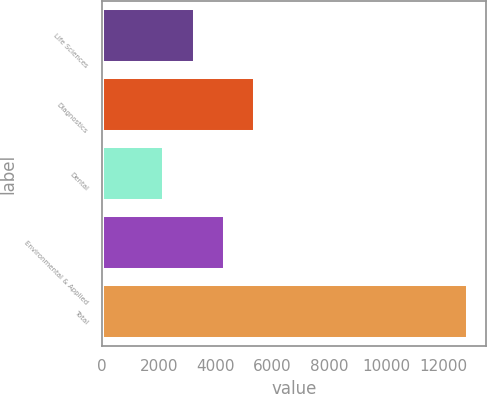<chart> <loc_0><loc_0><loc_500><loc_500><bar_chart><fcel>Life Sciences<fcel>Diagnostics<fcel>Dental<fcel>Environmental & Applied<fcel>Total<nl><fcel>3260.48<fcel>5395.24<fcel>2193.1<fcel>4327.86<fcel>12866.9<nl></chart> 